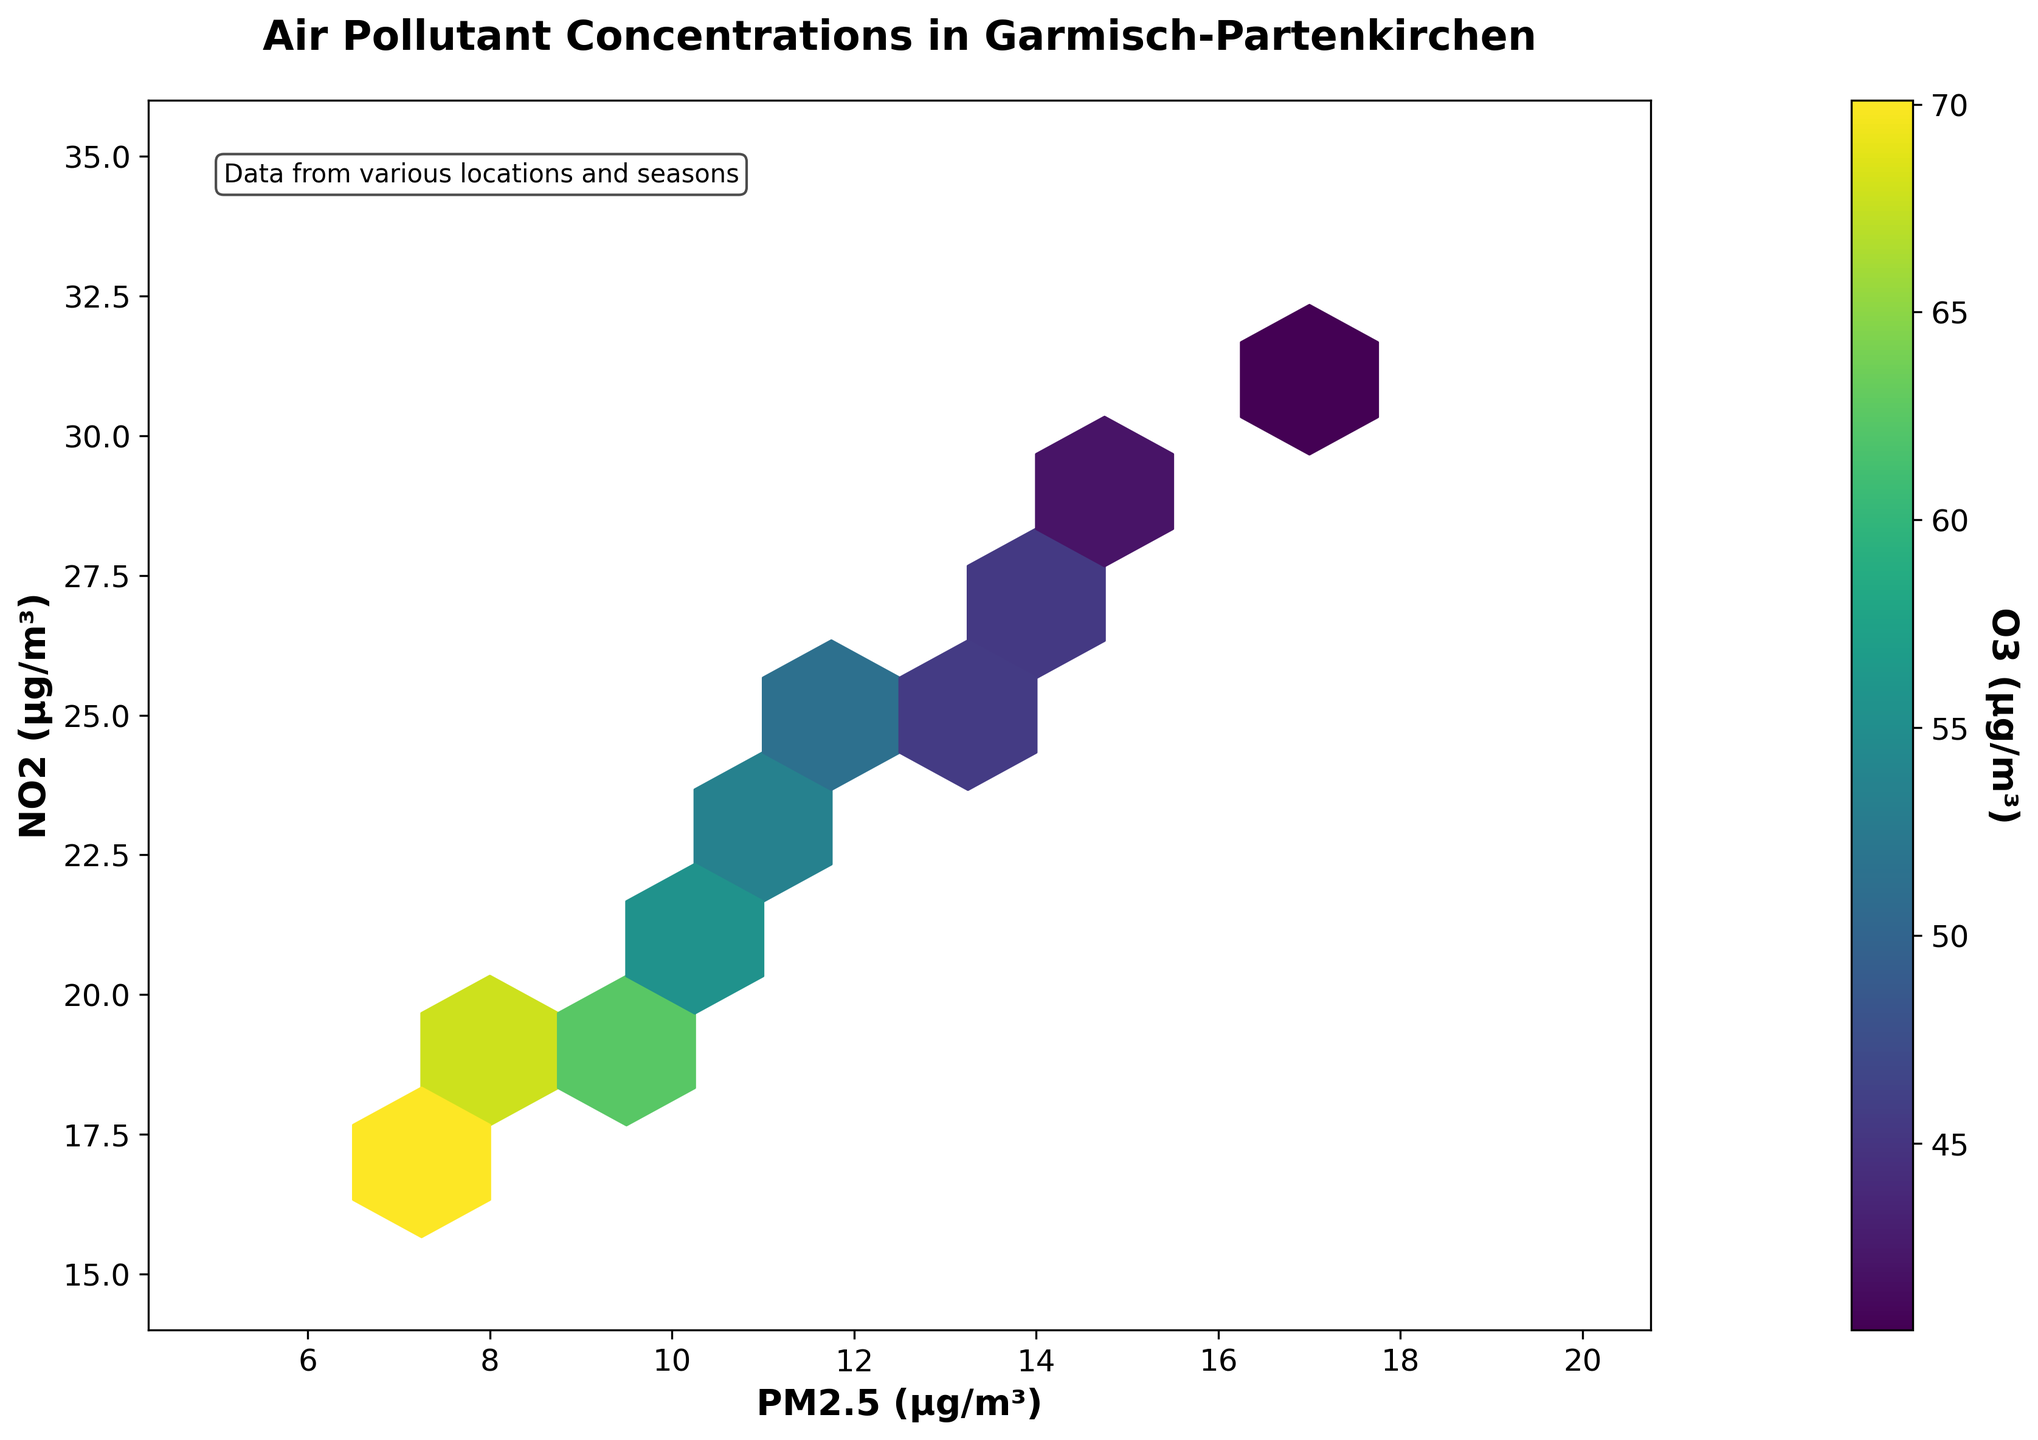What's the title of the figure? The title is located at the top of the figure and it reads "Air Pollutant Concentrations in Garmisch-Partenkirchen".
Answer: Air Pollutant Concentrations in Garmisch-Partenkirchen What do the x-axis and y-axis represent in this plot? The x-axis label reads "PM2.5 (µg/m³)" and the y-axis label reads "NO2 (µg/m³)", so the x-axis represents the concentration of PM2.5 in micrograms per cubic meter, and the y-axis represents the concentration of NO2 in micrograms per cubic meter.
Answer: PM2.5 concentration and NO2 concentration What color scale is used to represent O3 concentration in the plot? The color scale is shown as a color bar on the right side of the plot, labeled "O3 (µg/m³)". The colors range from dark purple to yellow-green, corresponding to low to high O3 concentrations.
Answer: Dark purple to yellow-green Which region of the plot has the highest average O3 concentration? Look at the hexagons with the brightest (yellow-green) colors. This indicates that the highest average O3 concentration is present in the region where PM2.5 concentrations are between approximately 7-11 µg/m³ and NO2 concentrations are between 16-24 µg/m³.
Answer: PM2.5: 7-11 µg/m³, NO2: 16-24 µg/m³ Are there more data points concentrated at higher or lower values of PM2.5? By observing the density of hexagons, more data points are concentrated at lower PM2.5 values, roughly between 7-13 µg/m³, as indicated by the higher number of hexagons in this region.
Answer: Lower values of PM2.5 What is the trend in O3 concentrations as PM2.5 levels increase? As the PM2.5 levels increase from 7 to 16 µg/m³, the O3 concentration tends to decrease, as indicated by the shift from yellow-green hexagons to darker purple hexagons.
Answer: Decrease Compare the NO2 concentrations for PM2.5 levels between 7 and 10 µg/m³ to those between 13 and 16 µg/m³. For PM2.5 levels between 7 and 10 µg/m³, NO2 concentrations are mostly below 24 µg/m³. For PM2.5 levels between 13 and 16 µg/m³, NO2 concentrations are generally higher, around 25-30 µg/m³.
Answer: Lower for 7-10 µg/m³, Higher for 13-16 µg/m³ How do the pollutant concentrations vary by location from the highest to lowest levels? Referencing the title and the hexbin plot, pollutant concentrations vary by location but tend to show higher PM2.5 and NO2 levels in certain street locations such as Bahnhofstraße and Hauptstraße, while locations like Alpspitzstraße have relatively lower concentrations.
Answer: Bahnforstraße > Hauptstraße > Others 